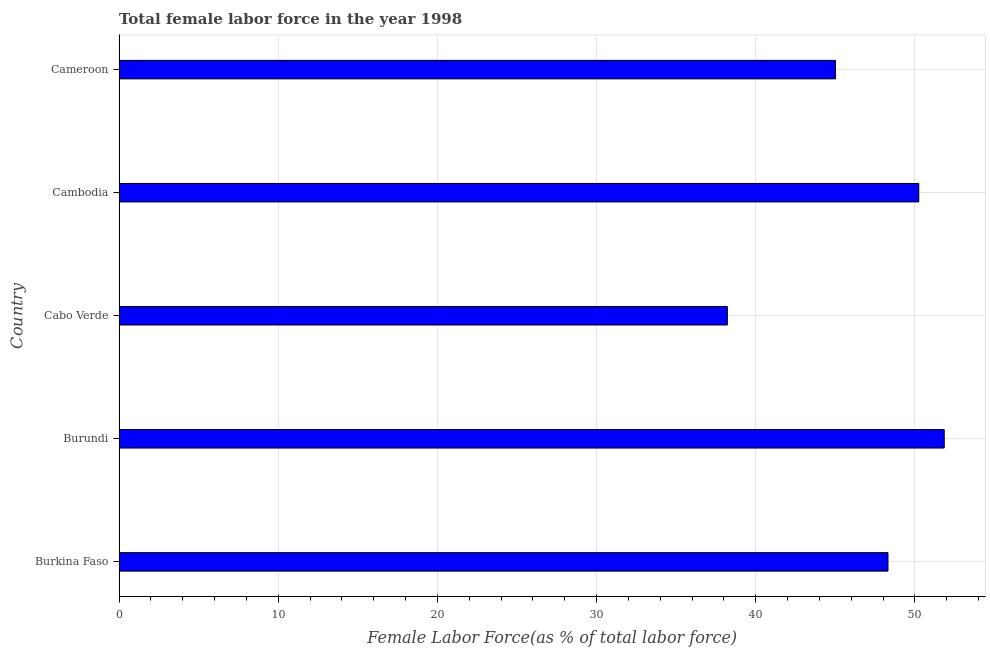What is the title of the graph?
Offer a very short reply. Total female labor force in the year 1998. What is the label or title of the X-axis?
Make the answer very short. Female Labor Force(as % of total labor force). What is the total female labor force in Burkina Faso?
Your answer should be compact. 48.31. Across all countries, what is the maximum total female labor force?
Keep it short and to the point. 51.85. Across all countries, what is the minimum total female labor force?
Make the answer very short. 38.22. In which country was the total female labor force maximum?
Keep it short and to the point. Burundi. In which country was the total female labor force minimum?
Your answer should be compact. Cabo Verde. What is the sum of the total female labor force?
Give a very brief answer. 233.64. What is the difference between the total female labor force in Burundi and Cabo Verde?
Provide a succinct answer. 13.63. What is the average total female labor force per country?
Your answer should be compact. 46.73. What is the median total female labor force?
Your answer should be very brief. 48.31. What is the ratio of the total female labor force in Burkina Faso to that in Cameroon?
Ensure brevity in your answer.  1.07. Is the total female labor force in Cambodia less than that in Cameroon?
Offer a very short reply. No. Is the difference between the total female labor force in Burkina Faso and Cameroon greater than the difference between any two countries?
Keep it short and to the point. No. What is the difference between the highest and the second highest total female labor force?
Keep it short and to the point. 1.6. What is the difference between the highest and the lowest total female labor force?
Offer a very short reply. 13.63. In how many countries, is the total female labor force greater than the average total female labor force taken over all countries?
Offer a very short reply. 3. Are all the bars in the graph horizontal?
Ensure brevity in your answer.  Yes. What is the Female Labor Force(as % of total labor force) in Burkina Faso?
Your answer should be very brief. 48.31. What is the Female Labor Force(as % of total labor force) in Burundi?
Give a very brief answer. 51.85. What is the Female Labor Force(as % of total labor force) in Cabo Verde?
Provide a short and direct response. 38.22. What is the Female Labor Force(as % of total labor force) in Cambodia?
Your answer should be very brief. 50.25. What is the Female Labor Force(as % of total labor force) in Cameroon?
Offer a very short reply. 45.01. What is the difference between the Female Labor Force(as % of total labor force) in Burkina Faso and Burundi?
Provide a short and direct response. -3.53. What is the difference between the Female Labor Force(as % of total labor force) in Burkina Faso and Cabo Verde?
Your response must be concise. 10.09. What is the difference between the Female Labor Force(as % of total labor force) in Burkina Faso and Cambodia?
Your answer should be very brief. -1.94. What is the difference between the Female Labor Force(as % of total labor force) in Burkina Faso and Cameroon?
Make the answer very short. 3.3. What is the difference between the Female Labor Force(as % of total labor force) in Burundi and Cabo Verde?
Make the answer very short. 13.63. What is the difference between the Female Labor Force(as % of total labor force) in Burundi and Cambodia?
Offer a very short reply. 1.6. What is the difference between the Female Labor Force(as % of total labor force) in Burundi and Cameroon?
Your response must be concise. 6.84. What is the difference between the Female Labor Force(as % of total labor force) in Cabo Verde and Cambodia?
Your answer should be very brief. -12.03. What is the difference between the Female Labor Force(as % of total labor force) in Cabo Verde and Cameroon?
Offer a very short reply. -6.79. What is the difference between the Female Labor Force(as % of total labor force) in Cambodia and Cameroon?
Offer a terse response. 5.24. What is the ratio of the Female Labor Force(as % of total labor force) in Burkina Faso to that in Burundi?
Your answer should be very brief. 0.93. What is the ratio of the Female Labor Force(as % of total labor force) in Burkina Faso to that in Cabo Verde?
Offer a very short reply. 1.26. What is the ratio of the Female Labor Force(as % of total labor force) in Burkina Faso to that in Cambodia?
Your response must be concise. 0.96. What is the ratio of the Female Labor Force(as % of total labor force) in Burkina Faso to that in Cameroon?
Give a very brief answer. 1.07. What is the ratio of the Female Labor Force(as % of total labor force) in Burundi to that in Cabo Verde?
Your answer should be compact. 1.36. What is the ratio of the Female Labor Force(as % of total labor force) in Burundi to that in Cambodia?
Provide a succinct answer. 1.03. What is the ratio of the Female Labor Force(as % of total labor force) in Burundi to that in Cameroon?
Give a very brief answer. 1.15. What is the ratio of the Female Labor Force(as % of total labor force) in Cabo Verde to that in Cambodia?
Provide a succinct answer. 0.76. What is the ratio of the Female Labor Force(as % of total labor force) in Cabo Verde to that in Cameroon?
Provide a succinct answer. 0.85. What is the ratio of the Female Labor Force(as % of total labor force) in Cambodia to that in Cameroon?
Offer a very short reply. 1.12. 